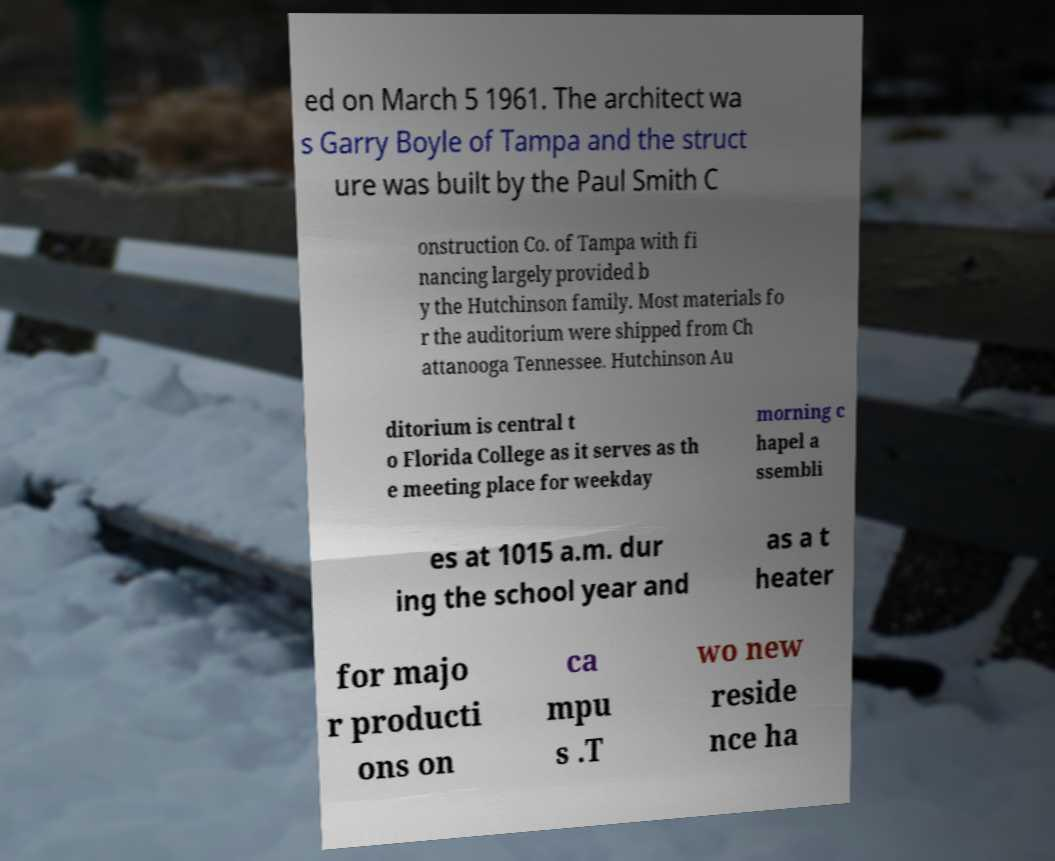Please identify and transcribe the text found in this image. ed on March 5 1961. The architect wa s Garry Boyle of Tampa and the struct ure was built by the Paul Smith C onstruction Co. of Tampa with fi nancing largely provided b y the Hutchinson family. Most materials fo r the auditorium were shipped from Ch attanooga Tennessee. Hutchinson Au ditorium is central t o Florida College as it serves as th e meeting place for weekday morning c hapel a ssembli es at 1015 a.m. dur ing the school year and as a t heater for majo r producti ons on ca mpu s .T wo new reside nce ha 